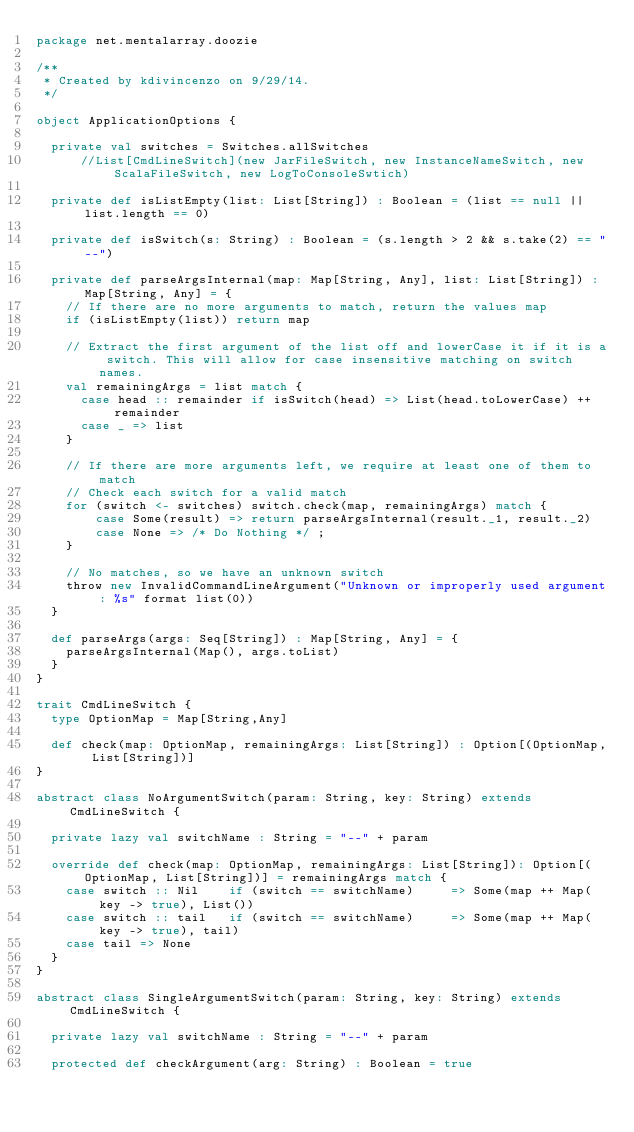<code> <loc_0><loc_0><loc_500><loc_500><_Scala_>package net.mentalarray.doozie

/**
 * Created by kdivincenzo on 9/29/14.
 */

object ApplicationOptions {

  private val switches = Switches.allSwitches
      //List[CmdLineSwitch](new JarFileSwitch, new InstanceNameSwitch, new ScalaFileSwitch, new LogToConsoleSwtich)

  private def isListEmpty(list: List[String]) : Boolean = (list == null || list.length == 0)

  private def isSwitch(s: String) : Boolean = (s.length > 2 && s.take(2) == "--")

  private def parseArgsInternal(map: Map[String, Any], list: List[String]) : Map[String, Any] = {
    // If there are no more arguments to match, return the values map
    if (isListEmpty(list)) return map

    // Extract the first argument of the list off and lowerCase it if it is a switch. This will allow for case insensitive matching on switch names.
    val remainingArgs = list match {
      case head :: remainder if isSwitch(head) => List(head.toLowerCase) ++ remainder
      case _ => list
    }

    // If there are more arguments left, we require at least one of them to match
    // Check each switch for a valid match
    for (switch <- switches) switch.check(map, remainingArgs) match {
        case Some(result) => return parseArgsInternal(result._1, result._2)
        case None => /* Do Nothing */ ;
    }

    // No matches, so we have an unknown switch
    throw new InvalidCommandLineArgument("Unknown or improperly used argument: %s" format list(0))
  }

  def parseArgs(args: Seq[String]) : Map[String, Any] = {
    parseArgsInternal(Map(), args.toList)
  }
}

trait CmdLineSwitch {
  type OptionMap = Map[String,Any]

  def check(map: OptionMap, remainingArgs: List[String]) : Option[(OptionMap, List[String])]
}

abstract class NoArgumentSwitch(param: String, key: String) extends CmdLineSwitch {

  private lazy val switchName : String = "--" + param

  override def check(map: OptionMap, remainingArgs: List[String]): Option[(OptionMap, List[String])] = remainingArgs match {
    case switch :: Nil    if (switch == switchName)     => Some(map ++ Map(key -> true), List())
    case switch :: tail   if (switch == switchName)     => Some(map ++ Map(key -> true), tail)
    case tail => None
  }
}

abstract class SingleArgumentSwitch(param: String, key: String) extends CmdLineSwitch {

  private lazy val switchName : String = "--" + param

  protected def checkArgument(arg: String) : Boolean = true
</code> 